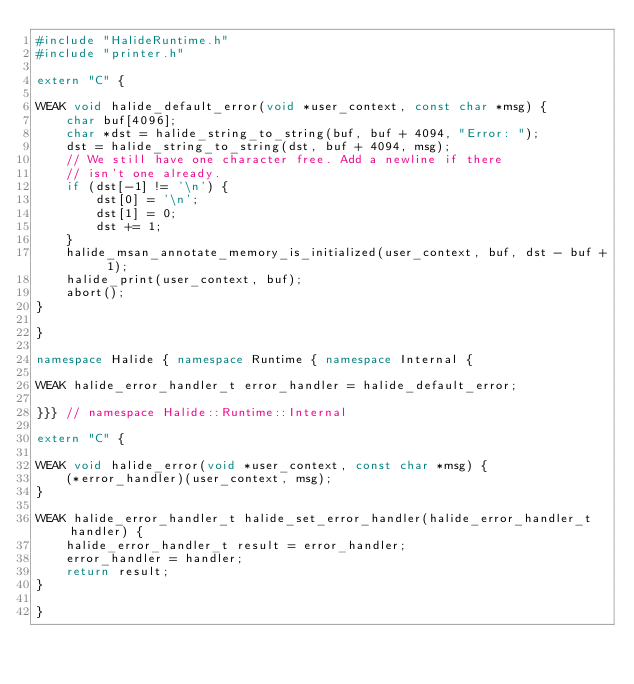Convert code to text. <code><loc_0><loc_0><loc_500><loc_500><_C++_>#include "HalideRuntime.h"
#include "printer.h"

extern "C" {

WEAK void halide_default_error(void *user_context, const char *msg) {
    char buf[4096];
    char *dst = halide_string_to_string(buf, buf + 4094, "Error: ");
    dst = halide_string_to_string(dst, buf + 4094, msg);
    // We still have one character free. Add a newline if there
    // isn't one already.
    if (dst[-1] != '\n') {
        dst[0] = '\n';
        dst[1] = 0;
        dst += 1;
    }
    halide_msan_annotate_memory_is_initialized(user_context, buf, dst - buf + 1);
    halide_print(user_context, buf);
    abort();
}

}

namespace Halide { namespace Runtime { namespace Internal {

WEAK halide_error_handler_t error_handler = halide_default_error;

}}} // namespace Halide::Runtime::Internal

extern "C" {

WEAK void halide_error(void *user_context, const char *msg) {
    (*error_handler)(user_context, msg);
}

WEAK halide_error_handler_t halide_set_error_handler(halide_error_handler_t handler) {
    halide_error_handler_t result = error_handler;
    error_handler = handler;
    return result;
}

}
</code> 